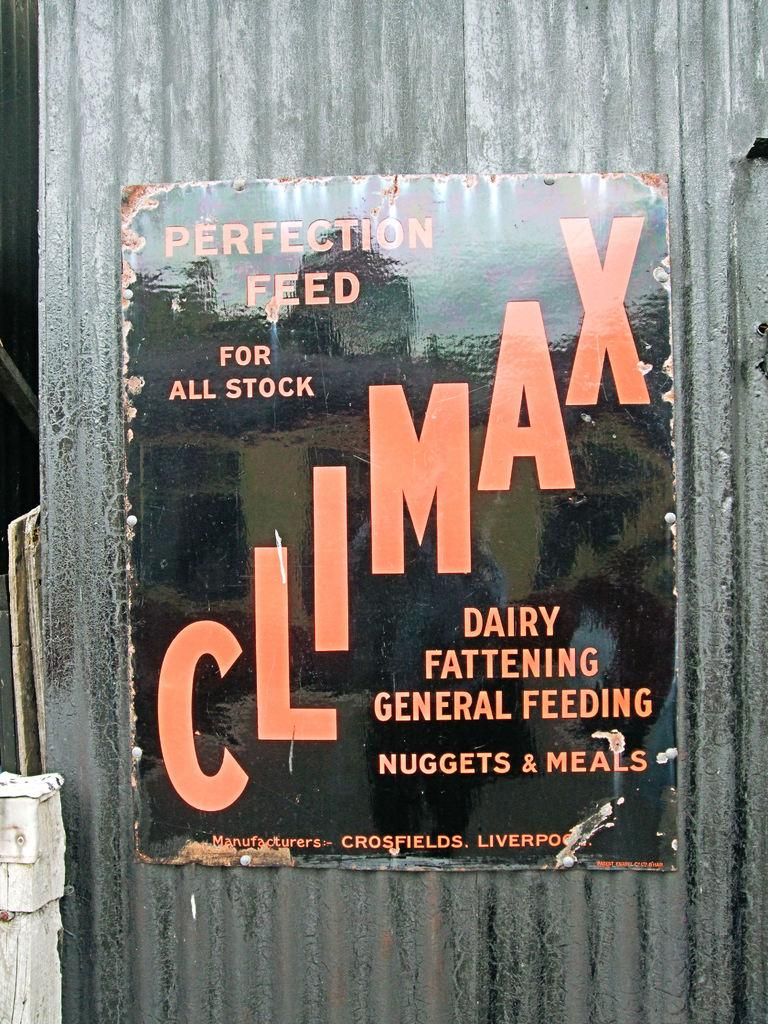<image>
Present a compact description of the photo's key features. A sign on a building that reads Climax and says Perfection feed for all stock 